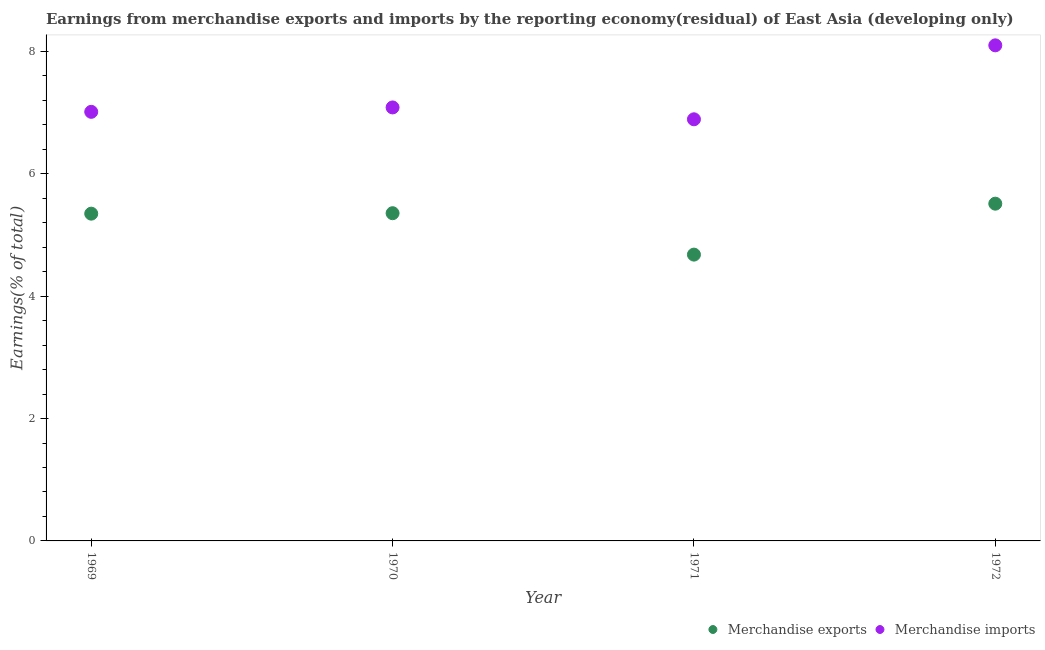How many different coloured dotlines are there?
Ensure brevity in your answer.  2. What is the earnings from merchandise imports in 1971?
Your answer should be compact. 6.89. Across all years, what is the maximum earnings from merchandise imports?
Your answer should be compact. 8.1. Across all years, what is the minimum earnings from merchandise exports?
Your answer should be very brief. 4.68. What is the total earnings from merchandise imports in the graph?
Your answer should be very brief. 29.08. What is the difference between the earnings from merchandise exports in 1970 and that in 1971?
Keep it short and to the point. 0.68. What is the difference between the earnings from merchandise exports in 1969 and the earnings from merchandise imports in 1970?
Ensure brevity in your answer.  -1.74. What is the average earnings from merchandise exports per year?
Provide a short and direct response. 5.22. In the year 1970, what is the difference between the earnings from merchandise imports and earnings from merchandise exports?
Your answer should be compact. 1.73. In how many years, is the earnings from merchandise imports greater than 2.4 %?
Your answer should be very brief. 4. What is the ratio of the earnings from merchandise exports in 1971 to that in 1972?
Give a very brief answer. 0.85. What is the difference between the highest and the second highest earnings from merchandise exports?
Provide a short and direct response. 0.16. What is the difference between the highest and the lowest earnings from merchandise exports?
Give a very brief answer. 0.83. Does the earnings from merchandise exports monotonically increase over the years?
Ensure brevity in your answer.  No. Is the earnings from merchandise imports strictly less than the earnings from merchandise exports over the years?
Provide a succinct answer. No. How many dotlines are there?
Offer a terse response. 2. What is the difference between two consecutive major ticks on the Y-axis?
Your answer should be compact. 2. Are the values on the major ticks of Y-axis written in scientific E-notation?
Make the answer very short. No. Does the graph contain any zero values?
Your answer should be compact. No. Does the graph contain grids?
Offer a terse response. No. Where does the legend appear in the graph?
Ensure brevity in your answer.  Bottom right. How are the legend labels stacked?
Your response must be concise. Horizontal. What is the title of the graph?
Your response must be concise. Earnings from merchandise exports and imports by the reporting economy(residual) of East Asia (developing only). What is the label or title of the Y-axis?
Ensure brevity in your answer.  Earnings(% of total). What is the Earnings(% of total) in Merchandise exports in 1969?
Your answer should be very brief. 5.35. What is the Earnings(% of total) of Merchandise imports in 1969?
Your answer should be compact. 7.01. What is the Earnings(% of total) in Merchandise exports in 1970?
Ensure brevity in your answer.  5.36. What is the Earnings(% of total) of Merchandise imports in 1970?
Your answer should be very brief. 7.08. What is the Earnings(% of total) of Merchandise exports in 1971?
Offer a very short reply. 4.68. What is the Earnings(% of total) in Merchandise imports in 1971?
Keep it short and to the point. 6.89. What is the Earnings(% of total) of Merchandise exports in 1972?
Offer a terse response. 5.51. What is the Earnings(% of total) of Merchandise imports in 1972?
Your response must be concise. 8.1. Across all years, what is the maximum Earnings(% of total) in Merchandise exports?
Keep it short and to the point. 5.51. Across all years, what is the maximum Earnings(% of total) in Merchandise imports?
Provide a short and direct response. 8.1. Across all years, what is the minimum Earnings(% of total) of Merchandise exports?
Make the answer very short. 4.68. Across all years, what is the minimum Earnings(% of total) in Merchandise imports?
Your answer should be very brief. 6.89. What is the total Earnings(% of total) of Merchandise exports in the graph?
Ensure brevity in your answer.  20.89. What is the total Earnings(% of total) of Merchandise imports in the graph?
Ensure brevity in your answer.  29.08. What is the difference between the Earnings(% of total) of Merchandise exports in 1969 and that in 1970?
Give a very brief answer. -0.01. What is the difference between the Earnings(% of total) of Merchandise imports in 1969 and that in 1970?
Provide a succinct answer. -0.07. What is the difference between the Earnings(% of total) of Merchandise exports in 1969 and that in 1971?
Offer a very short reply. 0.67. What is the difference between the Earnings(% of total) of Merchandise imports in 1969 and that in 1971?
Provide a succinct answer. 0.12. What is the difference between the Earnings(% of total) in Merchandise exports in 1969 and that in 1972?
Your answer should be compact. -0.16. What is the difference between the Earnings(% of total) in Merchandise imports in 1969 and that in 1972?
Make the answer very short. -1.09. What is the difference between the Earnings(% of total) of Merchandise exports in 1970 and that in 1971?
Your response must be concise. 0.68. What is the difference between the Earnings(% of total) of Merchandise imports in 1970 and that in 1971?
Your answer should be compact. 0.19. What is the difference between the Earnings(% of total) of Merchandise exports in 1970 and that in 1972?
Give a very brief answer. -0.16. What is the difference between the Earnings(% of total) of Merchandise imports in 1970 and that in 1972?
Make the answer very short. -1.01. What is the difference between the Earnings(% of total) of Merchandise exports in 1971 and that in 1972?
Ensure brevity in your answer.  -0.83. What is the difference between the Earnings(% of total) in Merchandise imports in 1971 and that in 1972?
Your response must be concise. -1.21. What is the difference between the Earnings(% of total) in Merchandise exports in 1969 and the Earnings(% of total) in Merchandise imports in 1970?
Provide a short and direct response. -1.74. What is the difference between the Earnings(% of total) in Merchandise exports in 1969 and the Earnings(% of total) in Merchandise imports in 1971?
Make the answer very short. -1.54. What is the difference between the Earnings(% of total) in Merchandise exports in 1969 and the Earnings(% of total) in Merchandise imports in 1972?
Your answer should be very brief. -2.75. What is the difference between the Earnings(% of total) in Merchandise exports in 1970 and the Earnings(% of total) in Merchandise imports in 1971?
Ensure brevity in your answer.  -1.53. What is the difference between the Earnings(% of total) in Merchandise exports in 1970 and the Earnings(% of total) in Merchandise imports in 1972?
Offer a very short reply. -2.74. What is the difference between the Earnings(% of total) of Merchandise exports in 1971 and the Earnings(% of total) of Merchandise imports in 1972?
Offer a terse response. -3.42. What is the average Earnings(% of total) in Merchandise exports per year?
Your answer should be compact. 5.22. What is the average Earnings(% of total) in Merchandise imports per year?
Offer a terse response. 7.27. In the year 1969, what is the difference between the Earnings(% of total) of Merchandise exports and Earnings(% of total) of Merchandise imports?
Your answer should be very brief. -1.66. In the year 1970, what is the difference between the Earnings(% of total) of Merchandise exports and Earnings(% of total) of Merchandise imports?
Your answer should be very brief. -1.73. In the year 1971, what is the difference between the Earnings(% of total) in Merchandise exports and Earnings(% of total) in Merchandise imports?
Make the answer very short. -2.21. In the year 1972, what is the difference between the Earnings(% of total) of Merchandise exports and Earnings(% of total) of Merchandise imports?
Offer a very short reply. -2.59. What is the ratio of the Earnings(% of total) in Merchandise imports in 1969 to that in 1970?
Make the answer very short. 0.99. What is the ratio of the Earnings(% of total) of Merchandise exports in 1969 to that in 1971?
Provide a succinct answer. 1.14. What is the ratio of the Earnings(% of total) in Merchandise imports in 1969 to that in 1971?
Your answer should be very brief. 1.02. What is the ratio of the Earnings(% of total) in Merchandise exports in 1969 to that in 1972?
Ensure brevity in your answer.  0.97. What is the ratio of the Earnings(% of total) in Merchandise imports in 1969 to that in 1972?
Make the answer very short. 0.87. What is the ratio of the Earnings(% of total) of Merchandise exports in 1970 to that in 1971?
Offer a very short reply. 1.14. What is the ratio of the Earnings(% of total) in Merchandise imports in 1970 to that in 1971?
Provide a succinct answer. 1.03. What is the ratio of the Earnings(% of total) of Merchandise exports in 1970 to that in 1972?
Provide a succinct answer. 0.97. What is the ratio of the Earnings(% of total) in Merchandise imports in 1970 to that in 1972?
Give a very brief answer. 0.87. What is the ratio of the Earnings(% of total) in Merchandise exports in 1971 to that in 1972?
Provide a short and direct response. 0.85. What is the ratio of the Earnings(% of total) in Merchandise imports in 1971 to that in 1972?
Your answer should be very brief. 0.85. What is the difference between the highest and the second highest Earnings(% of total) of Merchandise exports?
Offer a terse response. 0.16. What is the difference between the highest and the second highest Earnings(% of total) of Merchandise imports?
Ensure brevity in your answer.  1.01. What is the difference between the highest and the lowest Earnings(% of total) in Merchandise exports?
Offer a very short reply. 0.83. What is the difference between the highest and the lowest Earnings(% of total) of Merchandise imports?
Provide a succinct answer. 1.21. 